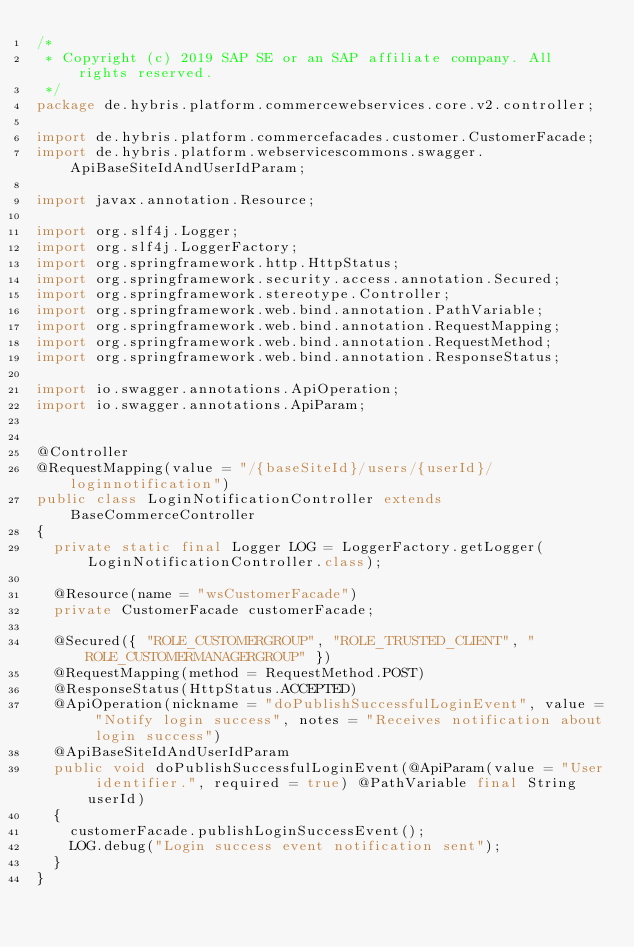Convert code to text. <code><loc_0><loc_0><loc_500><loc_500><_Java_>/*
 * Copyright (c) 2019 SAP SE or an SAP affiliate company. All rights reserved.
 */
package de.hybris.platform.commercewebservices.core.v2.controller;

import de.hybris.platform.commercefacades.customer.CustomerFacade;
import de.hybris.platform.webservicescommons.swagger.ApiBaseSiteIdAndUserIdParam;

import javax.annotation.Resource;

import org.slf4j.Logger;
import org.slf4j.LoggerFactory;
import org.springframework.http.HttpStatus;
import org.springframework.security.access.annotation.Secured;
import org.springframework.stereotype.Controller;
import org.springframework.web.bind.annotation.PathVariable;
import org.springframework.web.bind.annotation.RequestMapping;
import org.springframework.web.bind.annotation.RequestMethod;
import org.springframework.web.bind.annotation.ResponseStatus;

import io.swagger.annotations.ApiOperation;
import io.swagger.annotations.ApiParam;


@Controller
@RequestMapping(value = "/{baseSiteId}/users/{userId}/loginnotification")
public class LoginNotificationController extends BaseCommerceController
{
	private static final Logger LOG = LoggerFactory.getLogger(LoginNotificationController.class);

	@Resource(name = "wsCustomerFacade")
	private CustomerFacade customerFacade;

	@Secured({ "ROLE_CUSTOMERGROUP", "ROLE_TRUSTED_CLIENT", "ROLE_CUSTOMERMANAGERGROUP" })
	@RequestMapping(method = RequestMethod.POST)
	@ResponseStatus(HttpStatus.ACCEPTED)
	@ApiOperation(nickname = "doPublishSuccessfulLoginEvent", value = "Notify login success", notes = "Receives notification about login success")
	@ApiBaseSiteIdAndUserIdParam
	public void doPublishSuccessfulLoginEvent(@ApiParam(value = "User identifier.", required = true) @PathVariable final String userId)
	{
		customerFacade.publishLoginSuccessEvent();
		LOG.debug("Login success event notification sent");
	}
}
</code> 